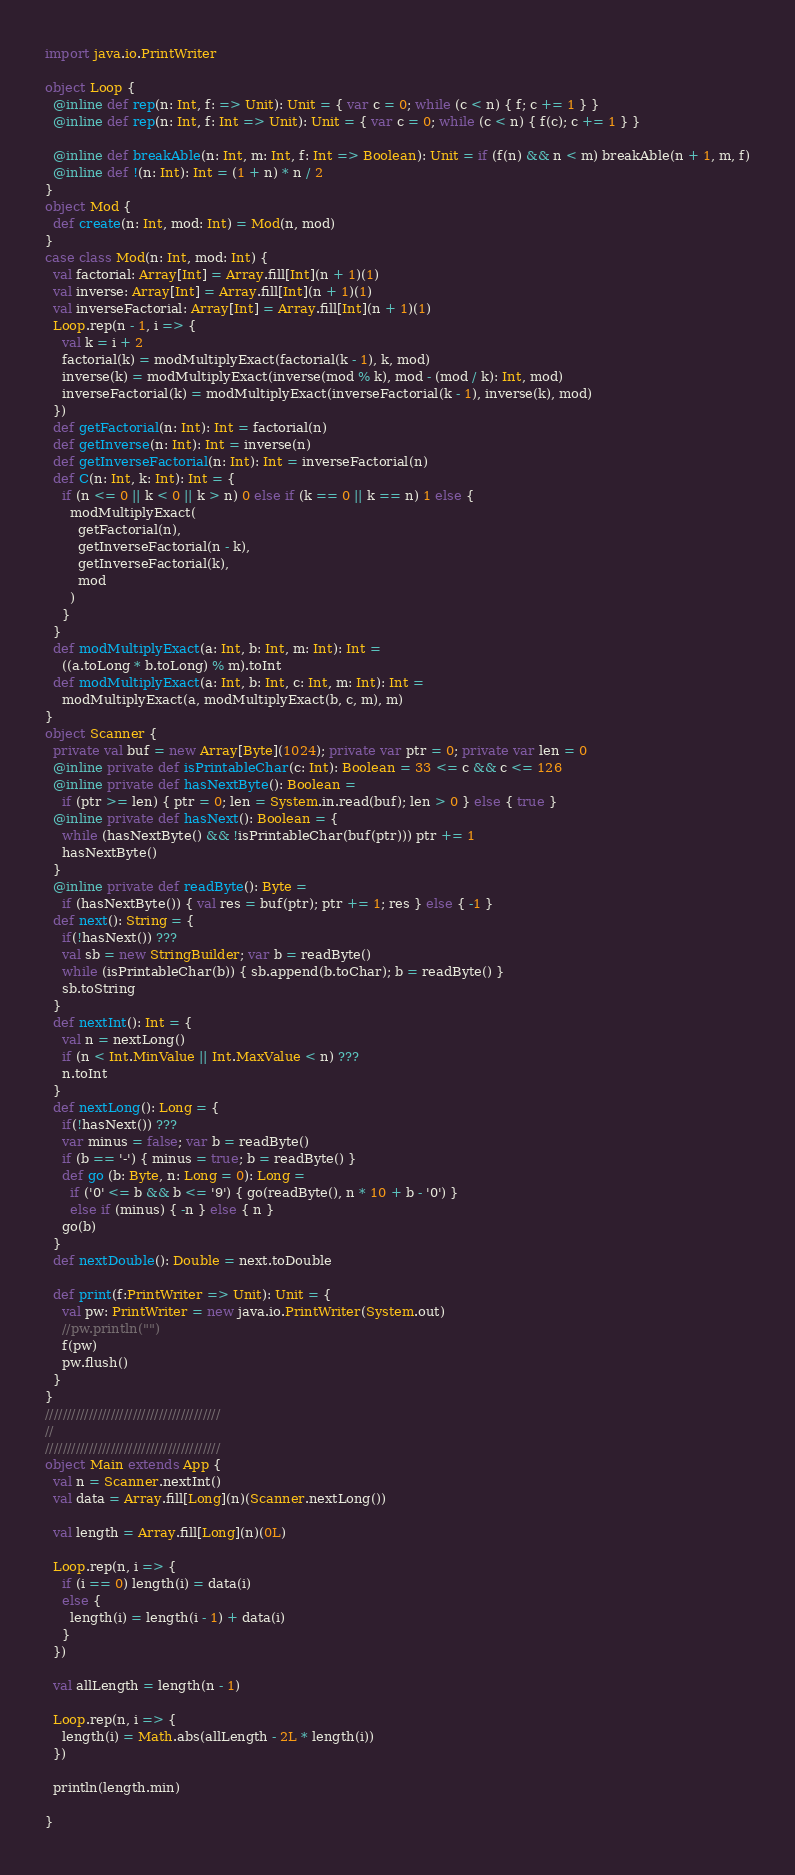<code> <loc_0><loc_0><loc_500><loc_500><_Scala_>import java.io.PrintWriter

object Loop {
  @inline def rep(n: Int, f: => Unit): Unit = { var c = 0; while (c < n) { f; c += 1 } }
  @inline def rep(n: Int, f: Int => Unit): Unit = { var c = 0; while (c < n) { f(c); c += 1 } }

  @inline def breakAble(n: Int, m: Int, f: Int => Boolean): Unit = if (f(n) && n < m) breakAble(n + 1, m, f)
  @inline def !(n: Int): Int = (1 + n) * n / 2
}
object Mod {
  def create(n: Int, mod: Int) = Mod(n, mod)
}
case class Mod(n: Int, mod: Int) {
  val factorial: Array[Int] = Array.fill[Int](n + 1)(1)
  val inverse: Array[Int] = Array.fill[Int](n + 1)(1)
  val inverseFactorial: Array[Int] = Array.fill[Int](n + 1)(1)
  Loop.rep(n - 1, i => {
    val k = i + 2
    factorial(k) = modMultiplyExact(factorial(k - 1), k, mod)
    inverse(k) = modMultiplyExact(inverse(mod % k), mod - (mod / k): Int, mod)
    inverseFactorial(k) = modMultiplyExact(inverseFactorial(k - 1), inverse(k), mod)
  })
  def getFactorial(n: Int): Int = factorial(n)
  def getInverse(n: Int): Int = inverse(n)
  def getInverseFactorial(n: Int): Int = inverseFactorial(n)
  def C(n: Int, k: Int): Int = {
    if (n <= 0 || k < 0 || k > n) 0 else if (k == 0 || k == n) 1 else {
      modMultiplyExact(
        getFactorial(n),
        getInverseFactorial(n - k),
        getInverseFactorial(k),
        mod
      )
    }
  }
  def modMultiplyExact(a: Int, b: Int, m: Int): Int =
    ((a.toLong * b.toLong) % m).toInt
  def modMultiplyExact(a: Int, b: Int, c: Int, m: Int): Int =
    modMultiplyExact(a, modMultiplyExact(b, c, m), m)
}
object Scanner {
  private val buf = new Array[Byte](1024); private var ptr = 0; private var len = 0
  @inline private def isPrintableChar(c: Int): Boolean = 33 <= c && c <= 126
  @inline private def hasNextByte(): Boolean =
    if (ptr >= len) { ptr = 0; len = System.in.read(buf); len > 0 } else { true }
  @inline private def hasNext(): Boolean = {
    while (hasNextByte() && !isPrintableChar(buf(ptr))) ptr += 1
    hasNextByte()
  }
  @inline private def readByte(): Byte =
    if (hasNextByte()) { val res = buf(ptr); ptr += 1; res } else { -1 }
  def next(): String = {
    if(!hasNext()) ???
    val sb = new StringBuilder; var b = readByte()
    while (isPrintableChar(b)) { sb.append(b.toChar); b = readByte() }
    sb.toString
  }
  def nextInt(): Int = {
    val n = nextLong()
    if (n < Int.MinValue || Int.MaxValue < n) ???
    n.toInt
  }
  def nextLong(): Long = {
    if(!hasNext()) ???
    var minus = false; var b = readByte()
    if (b == '-') { minus = true; b = readByte() }
    def go (b: Byte, n: Long = 0): Long =
      if ('0' <= b && b <= '9') { go(readByte(), n * 10 + b - '0') }
      else if (minus) { -n } else { n }
    go(b)
  }
  def nextDouble(): Double = next.toDouble

  def print(f:PrintWriter => Unit): Unit = {
    val pw: PrintWriter = new java.io.PrintWriter(System.out)
    //pw.println("")
    f(pw)
    pw.flush()
  }
}
////////////////////////////////////////
//
////////////////////////////////////////
object Main extends App {
  val n = Scanner.nextInt()
  val data = Array.fill[Long](n)(Scanner.nextLong())

  val length = Array.fill[Long](n)(0L)

  Loop.rep(n, i => {
    if (i == 0) length(i) = data(i)
    else {
      length(i) = length(i - 1) + data(i)
    }
  })

  val allLength = length(n - 1)

  Loop.rep(n, i => {
    length(i) = Math.abs(allLength - 2L * length(i))
  })

  println(length.min)

}</code> 